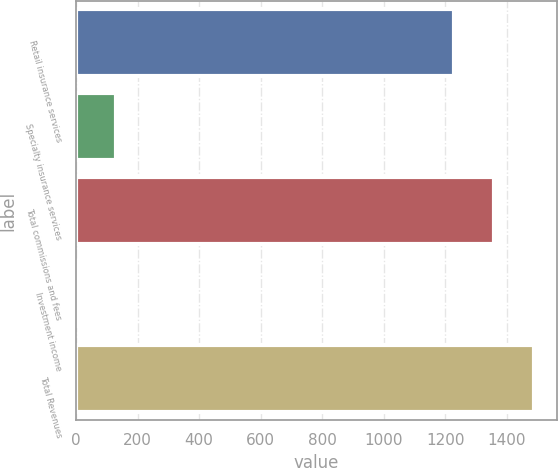Convert chart to OTSL. <chart><loc_0><loc_0><loc_500><loc_500><bar_chart><fcel>Retail insurance services<fcel>Specialty insurance services<fcel>Total commissions and fees<fcel>Investment income<fcel>Total Revenues<nl><fcel>1227<fcel>131.4<fcel>1357.4<fcel>1<fcel>1487.8<nl></chart> 